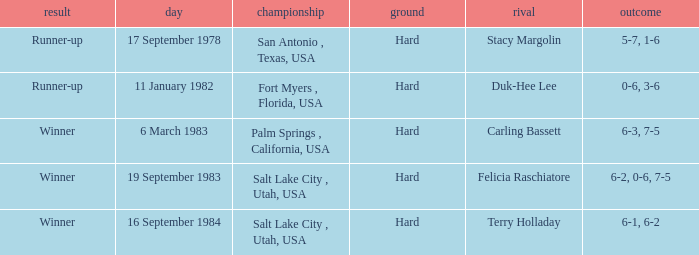Give me the full table as a dictionary. {'header': ['result', 'day', 'championship', 'ground', 'rival', 'outcome'], 'rows': [['Runner-up', '17 September 1978', 'San Antonio , Texas, USA', 'Hard', 'Stacy Margolin', '5-7, 1-6'], ['Runner-up', '11 January 1982', 'Fort Myers , Florida, USA', 'Hard', 'Duk-Hee Lee', '0-6, 3-6'], ['Winner', '6 March 1983', 'Palm Springs , California, USA', 'Hard', 'Carling Bassett', '6-3, 7-5'], ['Winner', '19 September 1983', 'Salt Lake City , Utah, USA', 'Hard', 'Felicia Raschiatore', '6-2, 0-6, 7-5'], ['Winner', '16 September 1984', 'Salt Lake City , Utah, USA', 'Hard', 'Terry Holladay', '6-1, 6-2']]} What was the score of the match against duk-hee lee? 0-6, 3-6. 